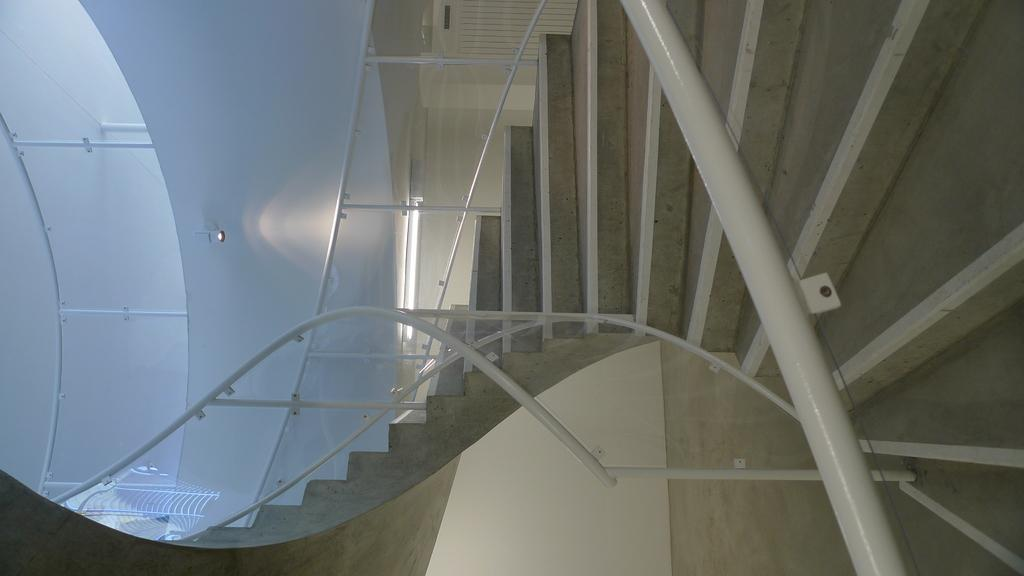What type of architectural feature is present in the image? There are steps in the image. What objects can be seen in the image that are long and thin? There are rods in the image. What type of structure is depicted in the image? There are walls in the image. What material is transparent and present in the image? There is glass in the image. What can be seen in the image that provides illumination? There is light in the image. What type of jam is being spread on the cloth in the image? There is no jam or cloth present in the image. What type of home is depicted in the image? The provided facts do not mention a home or any specific type of dwelling in the image. 